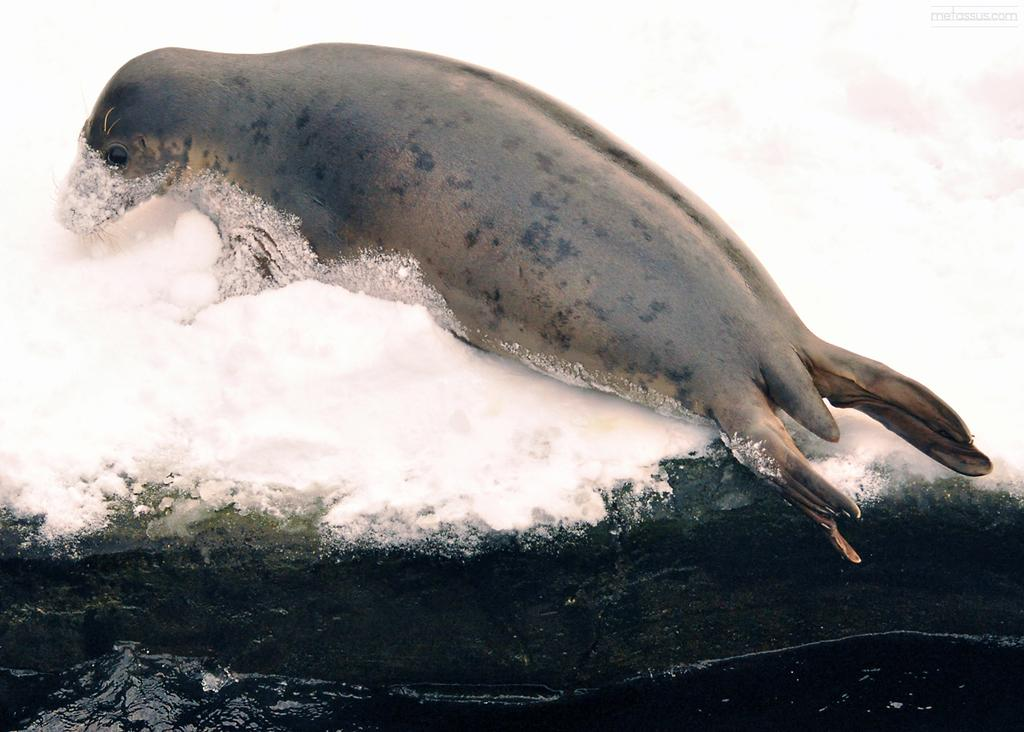What animal can be seen in the image? There is a seal in the image. What is the position of the seal in the image? The seal is lying on the ground. What type of terrain is visible in the image? There is snow on the ground. What can be seen at the bottom of the image? There is water visible at the bottom of the image. What type of laborer is working in the image? There is no laborer present in the image; it features a seal lying on the snowy ground. Can you describe the magic spell being cast by the seal in the image? There is no magic spell being cast in the image; it is a simple depiction of a seal lying on the ground. 